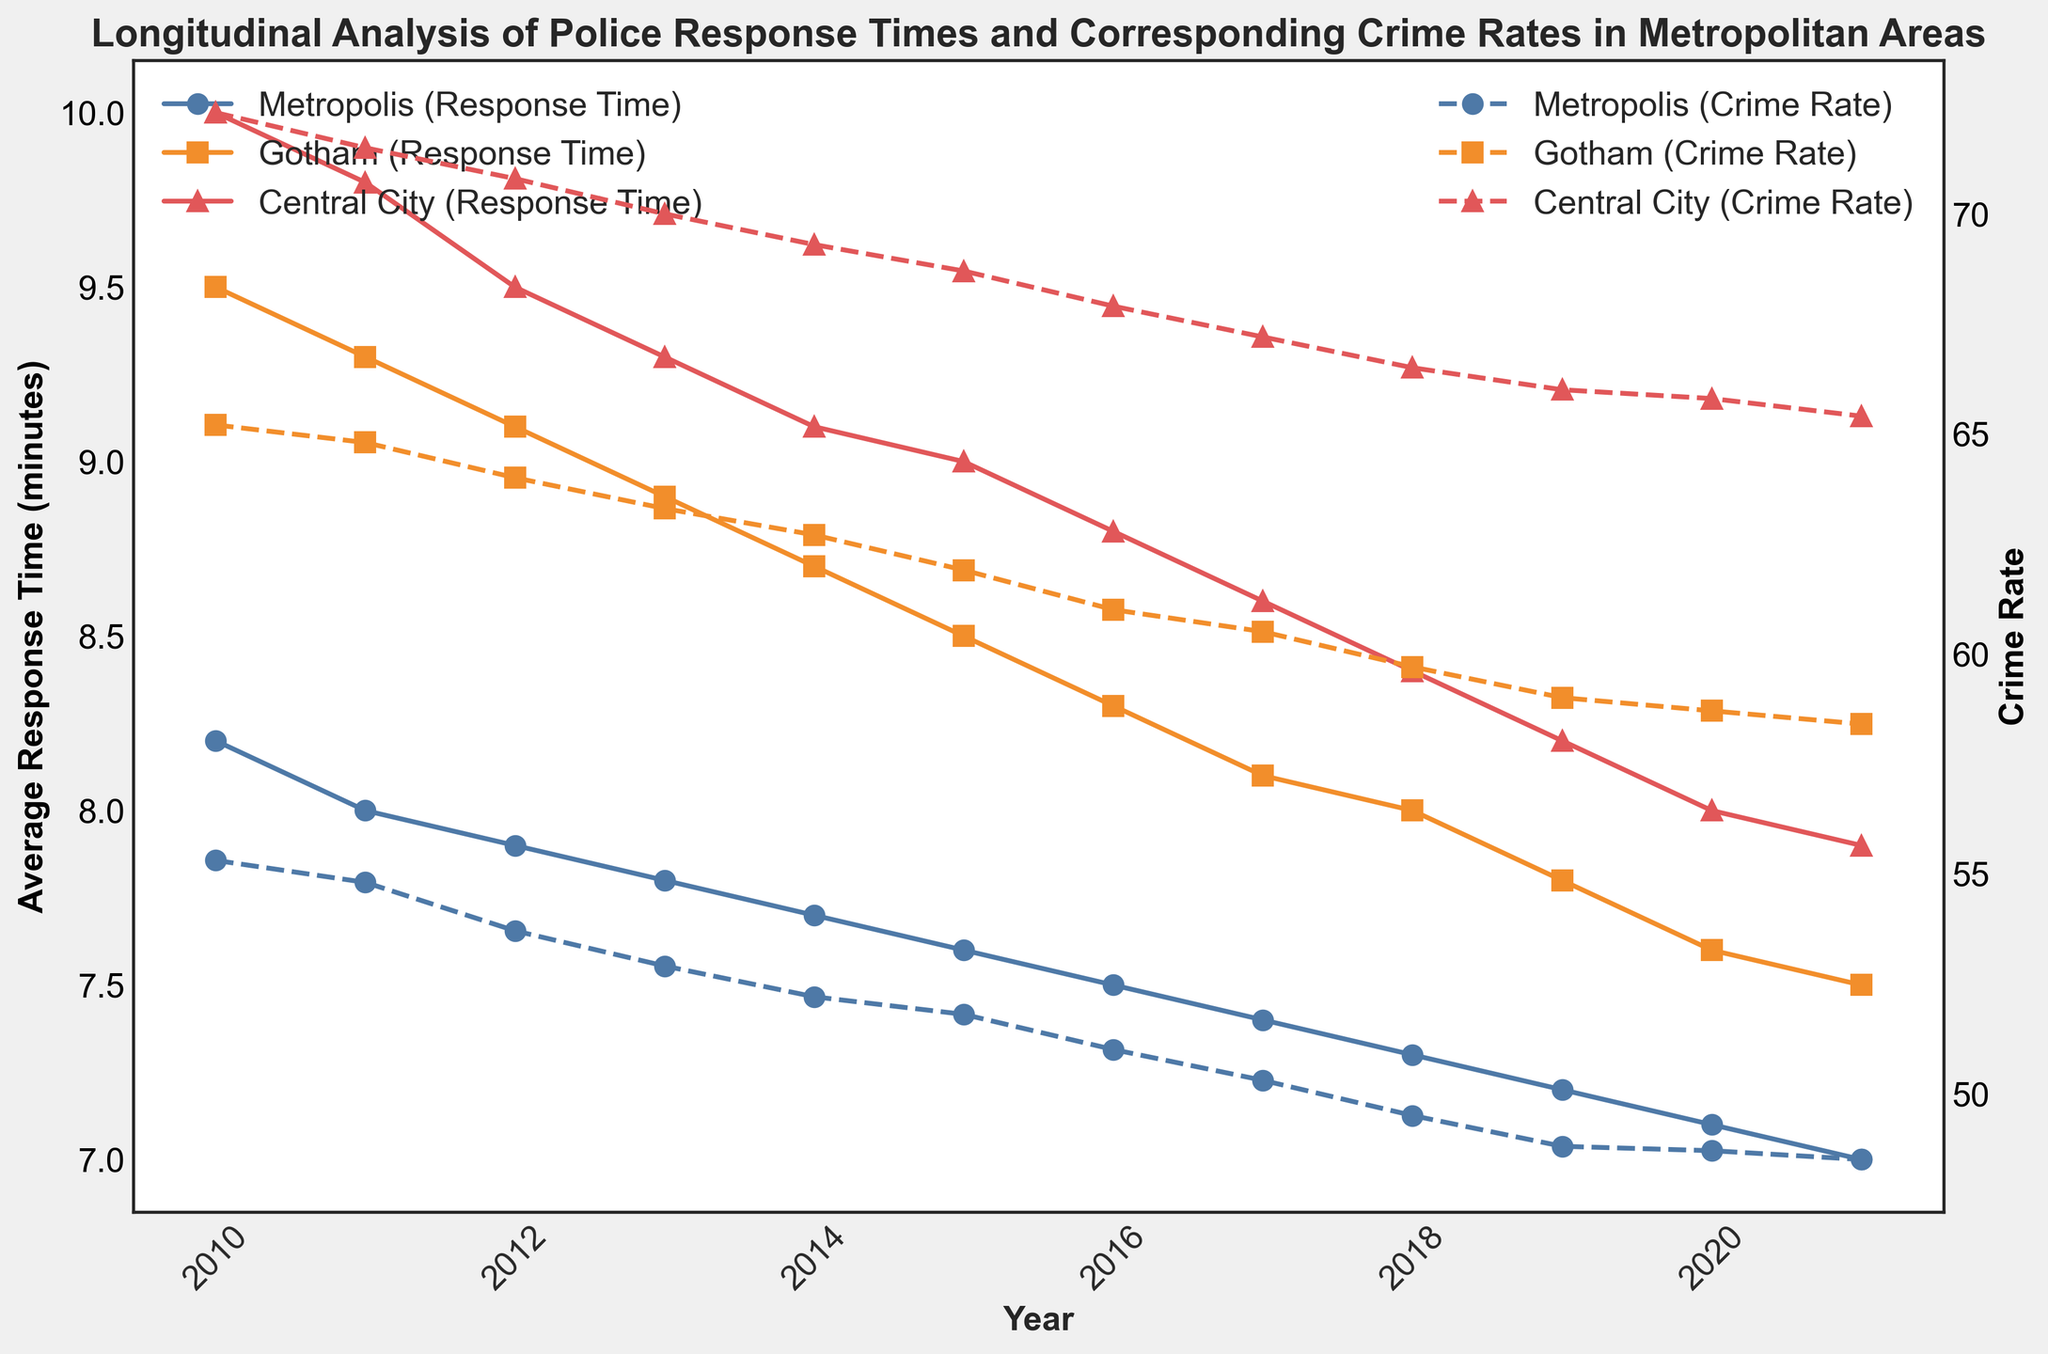What city has the lowest average police response time in 2021? The plot shows the average response times for each city in 2021. By comparing the final points on the lines, Central City has the lowest response time in 2021.
Answer: Central City How did the crime rate in Metropolis change from 2010 to 2021? The crime rate line for Metropolis shows a decrease from 55.3 in 2010 to 48.5 in 2021. The difference is calculated as 55.3 - 48.5 = 6.8.
Answer: Decreased by 6.8 Which city shows the greatest overall decrease in average response time from 2010 to 2021? By observing the slope of the average response time lines for each city, Central City experienced the greatest decrease from 10.0 in 2010 to 7.9 in 2021, a difference of 2.1 minutes.
Answer: Central City Compare the trends in crime rates for Gotham and Metropolis from 2010 to 2021. Which city had a larger reduction? Gotham's crime rate decreased from 65.2 to 58.4 (6.8 points), while Metropolis decreased from 55.3 to 48.5 (6.8 points). Both cities had the same reduction.
Answer: Both the same What is the average crime rate for Central City during the period from 2010 to 2021? To find the average crime rate, sum the crime rates for each year and divide by the number of years: (72.3 + 71.5 + 70.8 + 70.0 + 69.3 + 68.7 + 67.9 + 67.2 + 66.5 + 66.0 + 65.8 + 65.4) / 12 = 68.5.
Answer: 68.5 In which year did Gotham achieve the highest reduction in crime rate compared to the previous year? By examining the crime rate line for Gotham, the steepest decline is from 2015 to 2016, reducing from 61.9 to 61.0, which is a reduction of 0.9.
Answer: 2016 What is the difference between the lowest and highest average police response time in Metropolis from 2010 to 2021? The highest average response time in Metropolis is 8.2 minutes in 2010, and the lowest is 7.0 minutes in 2021. The difference is 8.2 - 7.0 = 1.2 minutes.
Answer: 1.2 Does Central City’s crime rate trend show more fluctuation compared to its average response time trend from 2010 to 2021? The crime rate line for Central City shows gradual decreases similar to its average response time line, indicating consistent trends with no sudden changes.
Answer: No What overall trend can be observed in both the average police response time and crime rates for all cities from 2010 to 2021? Observing all the lines over time, both average police response times and crime rates show a decreasing trend across all cities from 2010 to 2021.
Answer: Decreasing trend How many minutes did the average police response time in Gotham decrease by from the highest point to the lowest point between 2010 and 2021? The highest average response time in Gotham is 9.5 minutes in 2010, and the lowest is 7.5 minutes in 2021. The difference is 9.5 - 7.5 = 2.0 minutes.
Answer: 2.0 